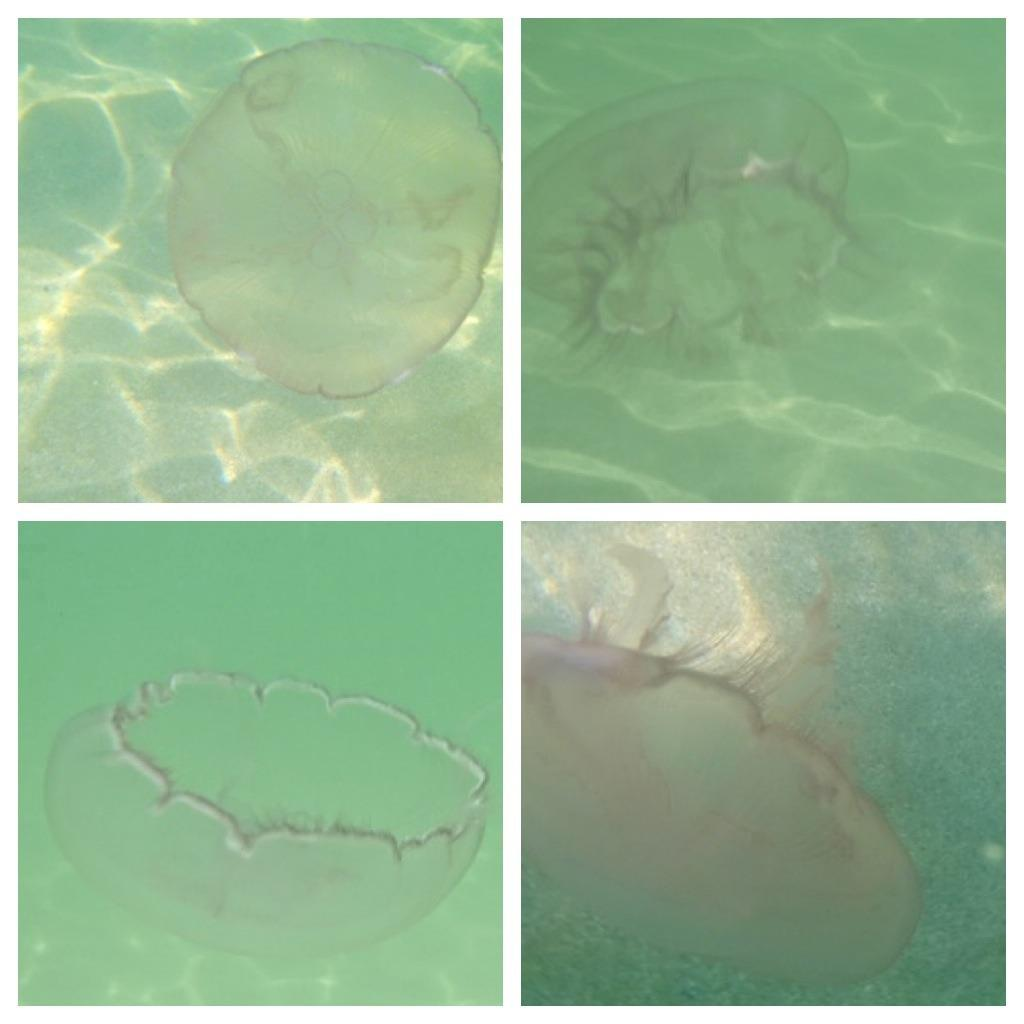What type of animal is in the image? The image contains a jellyfish. What is the jellyfish doing in the image? The jellyfish is swimming in the water. What type of wood is the jellyfish using to build its family home in the image? There is no wood or family home present in the image; it features a jellyfish swimming in the water. 